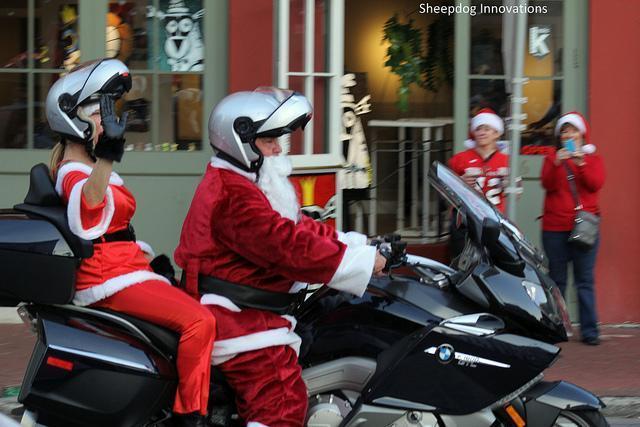How many people can be seen?
Give a very brief answer. 4. How many people are on the motorcycle?
Give a very brief answer. 2. How many people are there?
Give a very brief answer. 4. 